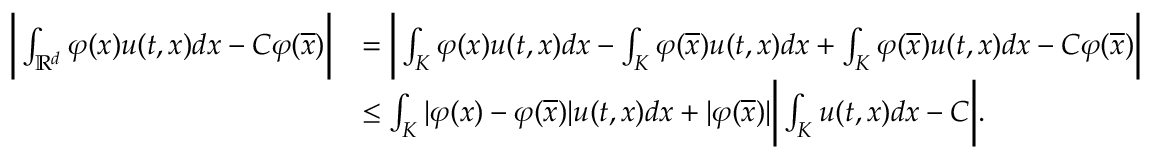<formula> <loc_0><loc_0><loc_500><loc_500>\begin{array} { r l } { \left | \int _ { \mathbb { R } ^ { d } } { \varphi ( x ) u ( t , x ) d x } - C \varphi ( \overline { x } ) \right | } & { = \left | \int _ { K } { \varphi ( x ) u ( t , x ) d x } - \int _ { K } { \varphi ( \overline { x } ) u ( t , x ) d x } + \int _ { K } { \varphi ( \overline { x } ) u ( t , x ) d x } - C \varphi ( \overline { x } ) \right | } \\ & { \leq \int _ { K } { | \varphi ( x ) - \varphi ( \overline { x } ) | u ( t , x ) d x } + | \varphi ( \overline { x } ) | \left | \int _ { K } { u ( t , x ) d x } - C \right | . } \end{array}</formula> 